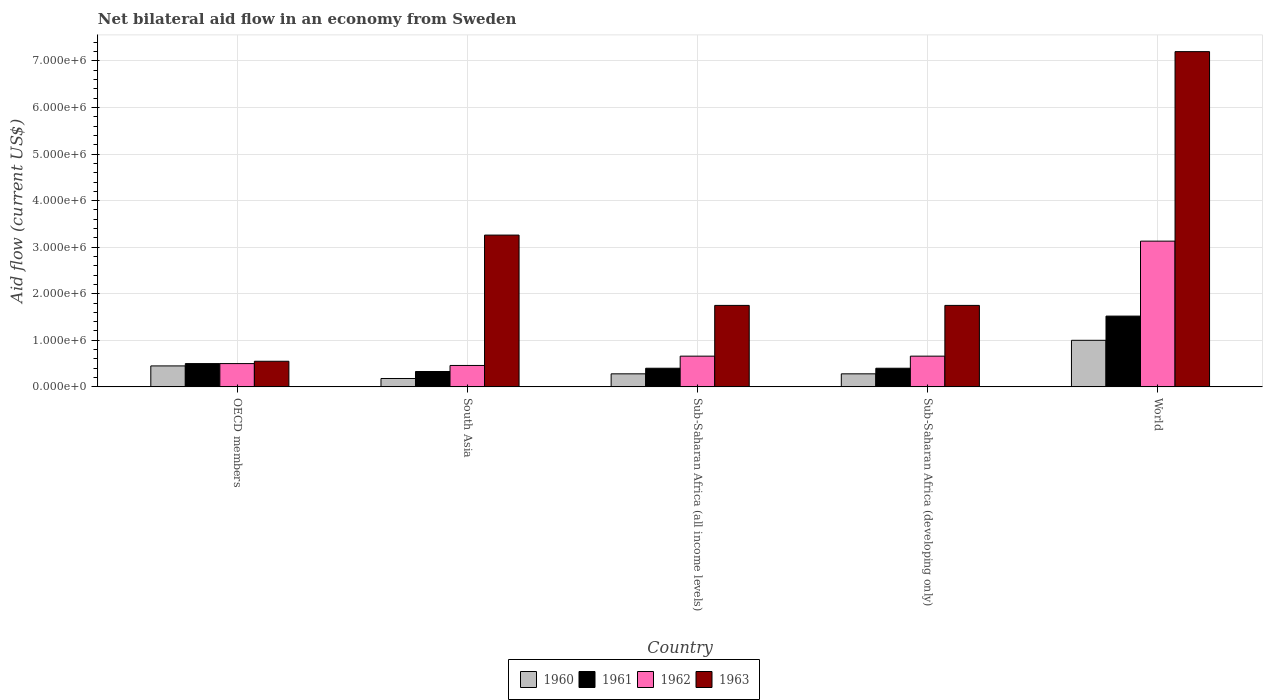How many different coloured bars are there?
Offer a terse response. 4. Are the number of bars per tick equal to the number of legend labels?
Your response must be concise. Yes. Are the number of bars on each tick of the X-axis equal?
Offer a terse response. Yes. What is the label of the 4th group of bars from the left?
Keep it short and to the point. Sub-Saharan Africa (developing only). What is the net bilateral aid flow in 1963 in Sub-Saharan Africa (developing only)?
Ensure brevity in your answer.  1.75e+06. Across all countries, what is the maximum net bilateral aid flow in 1961?
Offer a terse response. 1.52e+06. Across all countries, what is the minimum net bilateral aid flow in 1961?
Make the answer very short. 3.30e+05. In which country was the net bilateral aid flow in 1963 minimum?
Your response must be concise. OECD members. What is the total net bilateral aid flow in 1962 in the graph?
Keep it short and to the point. 5.41e+06. What is the difference between the net bilateral aid flow in 1962 in OECD members and that in Sub-Saharan Africa (developing only)?
Offer a very short reply. -1.60e+05. What is the difference between the net bilateral aid flow in 1963 in Sub-Saharan Africa (all income levels) and the net bilateral aid flow in 1960 in Sub-Saharan Africa (developing only)?
Your answer should be very brief. 1.47e+06. What is the average net bilateral aid flow in 1961 per country?
Your response must be concise. 6.30e+05. In how many countries, is the net bilateral aid flow in 1960 greater than 5200000 US$?
Offer a terse response. 0. What is the ratio of the net bilateral aid flow in 1961 in South Asia to that in Sub-Saharan Africa (all income levels)?
Give a very brief answer. 0.82. Is the difference between the net bilateral aid flow in 1962 in South Asia and World greater than the difference between the net bilateral aid flow in 1960 in South Asia and World?
Your response must be concise. No. What is the difference between the highest and the second highest net bilateral aid flow in 1960?
Offer a terse response. 7.20e+05. What is the difference between the highest and the lowest net bilateral aid flow in 1963?
Keep it short and to the point. 6.65e+06. Is it the case that in every country, the sum of the net bilateral aid flow in 1960 and net bilateral aid flow in 1961 is greater than the sum of net bilateral aid flow in 1963 and net bilateral aid flow in 1962?
Your response must be concise. No. What does the 2nd bar from the right in Sub-Saharan Africa (all income levels) represents?
Your answer should be compact. 1962. Is it the case that in every country, the sum of the net bilateral aid flow in 1963 and net bilateral aid flow in 1960 is greater than the net bilateral aid flow in 1962?
Make the answer very short. Yes. How many bars are there?
Your response must be concise. 20. How many countries are there in the graph?
Give a very brief answer. 5. Are the values on the major ticks of Y-axis written in scientific E-notation?
Your answer should be very brief. Yes. Where does the legend appear in the graph?
Your answer should be compact. Bottom center. How many legend labels are there?
Provide a short and direct response. 4. What is the title of the graph?
Your answer should be very brief. Net bilateral aid flow in an economy from Sweden. What is the Aid flow (current US$) of 1961 in OECD members?
Ensure brevity in your answer.  5.00e+05. What is the Aid flow (current US$) in 1963 in OECD members?
Ensure brevity in your answer.  5.50e+05. What is the Aid flow (current US$) of 1960 in South Asia?
Keep it short and to the point. 1.80e+05. What is the Aid flow (current US$) of 1962 in South Asia?
Keep it short and to the point. 4.60e+05. What is the Aid flow (current US$) in 1963 in South Asia?
Offer a very short reply. 3.26e+06. What is the Aid flow (current US$) in 1962 in Sub-Saharan Africa (all income levels)?
Provide a succinct answer. 6.60e+05. What is the Aid flow (current US$) of 1963 in Sub-Saharan Africa (all income levels)?
Provide a succinct answer. 1.75e+06. What is the Aid flow (current US$) of 1960 in Sub-Saharan Africa (developing only)?
Offer a terse response. 2.80e+05. What is the Aid flow (current US$) in 1961 in Sub-Saharan Africa (developing only)?
Give a very brief answer. 4.00e+05. What is the Aid flow (current US$) in 1963 in Sub-Saharan Africa (developing only)?
Your answer should be compact. 1.75e+06. What is the Aid flow (current US$) in 1961 in World?
Keep it short and to the point. 1.52e+06. What is the Aid flow (current US$) in 1962 in World?
Ensure brevity in your answer.  3.13e+06. What is the Aid flow (current US$) of 1963 in World?
Ensure brevity in your answer.  7.20e+06. Across all countries, what is the maximum Aid flow (current US$) of 1960?
Give a very brief answer. 1.00e+06. Across all countries, what is the maximum Aid flow (current US$) in 1961?
Make the answer very short. 1.52e+06. Across all countries, what is the maximum Aid flow (current US$) of 1962?
Provide a succinct answer. 3.13e+06. Across all countries, what is the maximum Aid flow (current US$) in 1963?
Make the answer very short. 7.20e+06. Across all countries, what is the minimum Aid flow (current US$) of 1960?
Offer a terse response. 1.80e+05. Across all countries, what is the minimum Aid flow (current US$) of 1961?
Keep it short and to the point. 3.30e+05. Across all countries, what is the minimum Aid flow (current US$) in 1963?
Your answer should be very brief. 5.50e+05. What is the total Aid flow (current US$) of 1960 in the graph?
Give a very brief answer. 2.19e+06. What is the total Aid flow (current US$) in 1961 in the graph?
Your answer should be very brief. 3.15e+06. What is the total Aid flow (current US$) in 1962 in the graph?
Your answer should be compact. 5.41e+06. What is the total Aid flow (current US$) in 1963 in the graph?
Offer a very short reply. 1.45e+07. What is the difference between the Aid flow (current US$) of 1960 in OECD members and that in South Asia?
Offer a very short reply. 2.70e+05. What is the difference between the Aid flow (current US$) in 1961 in OECD members and that in South Asia?
Give a very brief answer. 1.70e+05. What is the difference between the Aid flow (current US$) of 1962 in OECD members and that in South Asia?
Offer a very short reply. 4.00e+04. What is the difference between the Aid flow (current US$) in 1963 in OECD members and that in South Asia?
Your answer should be compact. -2.71e+06. What is the difference between the Aid flow (current US$) in 1961 in OECD members and that in Sub-Saharan Africa (all income levels)?
Keep it short and to the point. 1.00e+05. What is the difference between the Aid flow (current US$) of 1962 in OECD members and that in Sub-Saharan Africa (all income levels)?
Keep it short and to the point. -1.60e+05. What is the difference between the Aid flow (current US$) in 1963 in OECD members and that in Sub-Saharan Africa (all income levels)?
Offer a terse response. -1.20e+06. What is the difference between the Aid flow (current US$) of 1960 in OECD members and that in Sub-Saharan Africa (developing only)?
Ensure brevity in your answer.  1.70e+05. What is the difference between the Aid flow (current US$) of 1962 in OECD members and that in Sub-Saharan Africa (developing only)?
Your answer should be compact. -1.60e+05. What is the difference between the Aid flow (current US$) of 1963 in OECD members and that in Sub-Saharan Africa (developing only)?
Provide a short and direct response. -1.20e+06. What is the difference between the Aid flow (current US$) of 1960 in OECD members and that in World?
Keep it short and to the point. -5.50e+05. What is the difference between the Aid flow (current US$) of 1961 in OECD members and that in World?
Offer a very short reply. -1.02e+06. What is the difference between the Aid flow (current US$) in 1962 in OECD members and that in World?
Make the answer very short. -2.63e+06. What is the difference between the Aid flow (current US$) of 1963 in OECD members and that in World?
Your answer should be very brief. -6.65e+06. What is the difference between the Aid flow (current US$) of 1961 in South Asia and that in Sub-Saharan Africa (all income levels)?
Give a very brief answer. -7.00e+04. What is the difference between the Aid flow (current US$) in 1963 in South Asia and that in Sub-Saharan Africa (all income levels)?
Your response must be concise. 1.51e+06. What is the difference between the Aid flow (current US$) in 1960 in South Asia and that in Sub-Saharan Africa (developing only)?
Ensure brevity in your answer.  -1.00e+05. What is the difference between the Aid flow (current US$) in 1963 in South Asia and that in Sub-Saharan Africa (developing only)?
Provide a short and direct response. 1.51e+06. What is the difference between the Aid flow (current US$) of 1960 in South Asia and that in World?
Your response must be concise. -8.20e+05. What is the difference between the Aid flow (current US$) of 1961 in South Asia and that in World?
Make the answer very short. -1.19e+06. What is the difference between the Aid flow (current US$) of 1962 in South Asia and that in World?
Provide a succinct answer. -2.67e+06. What is the difference between the Aid flow (current US$) of 1963 in South Asia and that in World?
Your response must be concise. -3.94e+06. What is the difference between the Aid flow (current US$) of 1960 in Sub-Saharan Africa (all income levels) and that in Sub-Saharan Africa (developing only)?
Offer a terse response. 0. What is the difference between the Aid flow (current US$) in 1960 in Sub-Saharan Africa (all income levels) and that in World?
Your answer should be compact. -7.20e+05. What is the difference between the Aid flow (current US$) of 1961 in Sub-Saharan Africa (all income levels) and that in World?
Your answer should be very brief. -1.12e+06. What is the difference between the Aid flow (current US$) in 1962 in Sub-Saharan Africa (all income levels) and that in World?
Provide a short and direct response. -2.47e+06. What is the difference between the Aid flow (current US$) in 1963 in Sub-Saharan Africa (all income levels) and that in World?
Ensure brevity in your answer.  -5.45e+06. What is the difference between the Aid flow (current US$) in 1960 in Sub-Saharan Africa (developing only) and that in World?
Provide a succinct answer. -7.20e+05. What is the difference between the Aid flow (current US$) of 1961 in Sub-Saharan Africa (developing only) and that in World?
Offer a very short reply. -1.12e+06. What is the difference between the Aid flow (current US$) in 1962 in Sub-Saharan Africa (developing only) and that in World?
Ensure brevity in your answer.  -2.47e+06. What is the difference between the Aid flow (current US$) in 1963 in Sub-Saharan Africa (developing only) and that in World?
Your answer should be compact. -5.45e+06. What is the difference between the Aid flow (current US$) in 1960 in OECD members and the Aid flow (current US$) in 1961 in South Asia?
Your response must be concise. 1.20e+05. What is the difference between the Aid flow (current US$) of 1960 in OECD members and the Aid flow (current US$) of 1963 in South Asia?
Your answer should be very brief. -2.81e+06. What is the difference between the Aid flow (current US$) in 1961 in OECD members and the Aid flow (current US$) in 1962 in South Asia?
Make the answer very short. 4.00e+04. What is the difference between the Aid flow (current US$) in 1961 in OECD members and the Aid flow (current US$) in 1963 in South Asia?
Provide a short and direct response. -2.76e+06. What is the difference between the Aid flow (current US$) of 1962 in OECD members and the Aid flow (current US$) of 1963 in South Asia?
Provide a short and direct response. -2.76e+06. What is the difference between the Aid flow (current US$) of 1960 in OECD members and the Aid flow (current US$) of 1961 in Sub-Saharan Africa (all income levels)?
Your answer should be compact. 5.00e+04. What is the difference between the Aid flow (current US$) of 1960 in OECD members and the Aid flow (current US$) of 1962 in Sub-Saharan Africa (all income levels)?
Offer a very short reply. -2.10e+05. What is the difference between the Aid flow (current US$) in 1960 in OECD members and the Aid flow (current US$) in 1963 in Sub-Saharan Africa (all income levels)?
Your answer should be very brief. -1.30e+06. What is the difference between the Aid flow (current US$) of 1961 in OECD members and the Aid flow (current US$) of 1962 in Sub-Saharan Africa (all income levels)?
Give a very brief answer. -1.60e+05. What is the difference between the Aid flow (current US$) of 1961 in OECD members and the Aid flow (current US$) of 1963 in Sub-Saharan Africa (all income levels)?
Make the answer very short. -1.25e+06. What is the difference between the Aid flow (current US$) of 1962 in OECD members and the Aid flow (current US$) of 1963 in Sub-Saharan Africa (all income levels)?
Provide a succinct answer. -1.25e+06. What is the difference between the Aid flow (current US$) of 1960 in OECD members and the Aid flow (current US$) of 1961 in Sub-Saharan Africa (developing only)?
Provide a short and direct response. 5.00e+04. What is the difference between the Aid flow (current US$) of 1960 in OECD members and the Aid flow (current US$) of 1962 in Sub-Saharan Africa (developing only)?
Your answer should be compact. -2.10e+05. What is the difference between the Aid flow (current US$) in 1960 in OECD members and the Aid flow (current US$) in 1963 in Sub-Saharan Africa (developing only)?
Give a very brief answer. -1.30e+06. What is the difference between the Aid flow (current US$) of 1961 in OECD members and the Aid flow (current US$) of 1962 in Sub-Saharan Africa (developing only)?
Provide a succinct answer. -1.60e+05. What is the difference between the Aid flow (current US$) of 1961 in OECD members and the Aid flow (current US$) of 1963 in Sub-Saharan Africa (developing only)?
Make the answer very short. -1.25e+06. What is the difference between the Aid flow (current US$) in 1962 in OECD members and the Aid flow (current US$) in 1963 in Sub-Saharan Africa (developing only)?
Make the answer very short. -1.25e+06. What is the difference between the Aid flow (current US$) of 1960 in OECD members and the Aid flow (current US$) of 1961 in World?
Ensure brevity in your answer.  -1.07e+06. What is the difference between the Aid flow (current US$) in 1960 in OECD members and the Aid flow (current US$) in 1962 in World?
Make the answer very short. -2.68e+06. What is the difference between the Aid flow (current US$) of 1960 in OECD members and the Aid flow (current US$) of 1963 in World?
Give a very brief answer. -6.75e+06. What is the difference between the Aid flow (current US$) of 1961 in OECD members and the Aid flow (current US$) of 1962 in World?
Offer a terse response. -2.63e+06. What is the difference between the Aid flow (current US$) in 1961 in OECD members and the Aid flow (current US$) in 1963 in World?
Your answer should be very brief. -6.70e+06. What is the difference between the Aid flow (current US$) of 1962 in OECD members and the Aid flow (current US$) of 1963 in World?
Ensure brevity in your answer.  -6.70e+06. What is the difference between the Aid flow (current US$) of 1960 in South Asia and the Aid flow (current US$) of 1962 in Sub-Saharan Africa (all income levels)?
Your response must be concise. -4.80e+05. What is the difference between the Aid flow (current US$) in 1960 in South Asia and the Aid flow (current US$) in 1963 in Sub-Saharan Africa (all income levels)?
Offer a very short reply. -1.57e+06. What is the difference between the Aid flow (current US$) in 1961 in South Asia and the Aid flow (current US$) in 1962 in Sub-Saharan Africa (all income levels)?
Provide a succinct answer. -3.30e+05. What is the difference between the Aid flow (current US$) in 1961 in South Asia and the Aid flow (current US$) in 1963 in Sub-Saharan Africa (all income levels)?
Your response must be concise. -1.42e+06. What is the difference between the Aid flow (current US$) in 1962 in South Asia and the Aid flow (current US$) in 1963 in Sub-Saharan Africa (all income levels)?
Your answer should be very brief. -1.29e+06. What is the difference between the Aid flow (current US$) in 1960 in South Asia and the Aid flow (current US$) in 1962 in Sub-Saharan Africa (developing only)?
Ensure brevity in your answer.  -4.80e+05. What is the difference between the Aid flow (current US$) in 1960 in South Asia and the Aid flow (current US$) in 1963 in Sub-Saharan Africa (developing only)?
Offer a terse response. -1.57e+06. What is the difference between the Aid flow (current US$) in 1961 in South Asia and the Aid flow (current US$) in 1962 in Sub-Saharan Africa (developing only)?
Keep it short and to the point. -3.30e+05. What is the difference between the Aid flow (current US$) in 1961 in South Asia and the Aid flow (current US$) in 1963 in Sub-Saharan Africa (developing only)?
Offer a very short reply. -1.42e+06. What is the difference between the Aid flow (current US$) of 1962 in South Asia and the Aid flow (current US$) of 1963 in Sub-Saharan Africa (developing only)?
Offer a terse response. -1.29e+06. What is the difference between the Aid flow (current US$) of 1960 in South Asia and the Aid flow (current US$) of 1961 in World?
Your answer should be compact. -1.34e+06. What is the difference between the Aid flow (current US$) of 1960 in South Asia and the Aid flow (current US$) of 1962 in World?
Offer a very short reply. -2.95e+06. What is the difference between the Aid flow (current US$) of 1960 in South Asia and the Aid flow (current US$) of 1963 in World?
Offer a terse response. -7.02e+06. What is the difference between the Aid flow (current US$) in 1961 in South Asia and the Aid flow (current US$) in 1962 in World?
Offer a terse response. -2.80e+06. What is the difference between the Aid flow (current US$) of 1961 in South Asia and the Aid flow (current US$) of 1963 in World?
Offer a terse response. -6.87e+06. What is the difference between the Aid flow (current US$) in 1962 in South Asia and the Aid flow (current US$) in 1963 in World?
Offer a terse response. -6.74e+06. What is the difference between the Aid flow (current US$) of 1960 in Sub-Saharan Africa (all income levels) and the Aid flow (current US$) of 1962 in Sub-Saharan Africa (developing only)?
Keep it short and to the point. -3.80e+05. What is the difference between the Aid flow (current US$) of 1960 in Sub-Saharan Africa (all income levels) and the Aid flow (current US$) of 1963 in Sub-Saharan Africa (developing only)?
Offer a very short reply. -1.47e+06. What is the difference between the Aid flow (current US$) of 1961 in Sub-Saharan Africa (all income levels) and the Aid flow (current US$) of 1962 in Sub-Saharan Africa (developing only)?
Your answer should be compact. -2.60e+05. What is the difference between the Aid flow (current US$) of 1961 in Sub-Saharan Africa (all income levels) and the Aid flow (current US$) of 1963 in Sub-Saharan Africa (developing only)?
Your answer should be compact. -1.35e+06. What is the difference between the Aid flow (current US$) in 1962 in Sub-Saharan Africa (all income levels) and the Aid flow (current US$) in 1963 in Sub-Saharan Africa (developing only)?
Provide a short and direct response. -1.09e+06. What is the difference between the Aid flow (current US$) of 1960 in Sub-Saharan Africa (all income levels) and the Aid flow (current US$) of 1961 in World?
Your answer should be compact. -1.24e+06. What is the difference between the Aid flow (current US$) of 1960 in Sub-Saharan Africa (all income levels) and the Aid flow (current US$) of 1962 in World?
Ensure brevity in your answer.  -2.85e+06. What is the difference between the Aid flow (current US$) in 1960 in Sub-Saharan Africa (all income levels) and the Aid flow (current US$) in 1963 in World?
Give a very brief answer. -6.92e+06. What is the difference between the Aid flow (current US$) in 1961 in Sub-Saharan Africa (all income levels) and the Aid flow (current US$) in 1962 in World?
Your answer should be very brief. -2.73e+06. What is the difference between the Aid flow (current US$) of 1961 in Sub-Saharan Africa (all income levels) and the Aid flow (current US$) of 1963 in World?
Make the answer very short. -6.80e+06. What is the difference between the Aid flow (current US$) of 1962 in Sub-Saharan Africa (all income levels) and the Aid flow (current US$) of 1963 in World?
Keep it short and to the point. -6.54e+06. What is the difference between the Aid flow (current US$) of 1960 in Sub-Saharan Africa (developing only) and the Aid flow (current US$) of 1961 in World?
Provide a short and direct response. -1.24e+06. What is the difference between the Aid flow (current US$) in 1960 in Sub-Saharan Africa (developing only) and the Aid flow (current US$) in 1962 in World?
Offer a very short reply. -2.85e+06. What is the difference between the Aid flow (current US$) of 1960 in Sub-Saharan Africa (developing only) and the Aid flow (current US$) of 1963 in World?
Provide a succinct answer. -6.92e+06. What is the difference between the Aid flow (current US$) of 1961 in Sub-Saharan Africa (developing only) and the Aid flow (current US$) of 1962 in World?
Offer a terse response. -2.73e+06. What is the difference between the Aid flow (current US$) of 1961 in Sub-Saharan Africa (developing only) and the Aid flow (current US$) of 1963 in World?
Provide a succinct answer. -6.80e+06. What is the difference between the Aid flow (current US$) in 1962 in Sub-Saharan Africa (developing only) and the Aid flow (current US$) in 1963 in World?
Offer a terse response. -6.54e+06. What is the average Aid flow (current US$) of 1960 per country?
Provide a succinct answer. 4.38e+05. What is the average Aid flow (current US$) in 1961 per country?
Offer a terse response. 6.30e+05. What is the average Aid flow (current US$) of 1962 per country?
Your answer should be compact. 1.08e+06. What is the average Aid flow (current US$) of 1963 per country?
Your answer should be compact. 2.90e+06. What is the difference between the Aid flow (current US$) in 1960 and Aid flow (current US$) in 1961 in OECD members?
Your answer should be compact. -5.00e+04. What is the difference between the Aid flow (current US$) of 1960 and Aid flow (current US$) of 1962 in OECD members?
Your answer should be very brief. -5.00e+04. What is the difference between the Aid flow (current US$) of 1960 and Aid flow (current US$) of 1963 in OECD members?
Your answer should be very brief. -1.00e+05. What is the difference between the Aid flow (current US$) of 1962 and Aid flow (current US$) of 1963 in OECD members?
Your response must be concise. -5.00e+04. What is the difference between the Aid flow (current US$) in 1960 and Aid flow (current US$) in 1962 in South Asia?
Make the answer very short. -2.80e+05. What is the difference between the Aid flow (current US$) in 1960 and Aid flow (current US$) in 1963 in South Asia?
Ensure brevity in your answer.  -3.08e+06. What is the difference between the Aid flow (current US$) of 1961 and Aid flow (current US$) of 1962 in South Asia?
Offer a very short reply. -1.30e+05. What is the difference between the Aid flow (current US$) in 1961 and Aid flow (current US$) in 1963 in South Asia?
Ensure brevity in your answer.  -2.93e+06. What is the difference between the Aid flow (current US$) of 1962 and Aid flow (current US$) of 1963 in South Asia?
Ensure brevity in your answer.  -2.80e+06. What is the difference between the Aid flow (current US$) of 1960 and Aid flow (current US$) of 1961 in Sub-Saharan Africa (all income levels)?
Provide a short and direct response. -1.20e+05. What is the difference between the Aid flow (current US$) in 1960 and Aid flow (current US$) in 1962 in Sub-Saharan Africa (all income levels)?
Your answer should be very brief. -3.80e+05. What is the difference between the Aid flow (current US$) in 1960 and Aid flow (current US$) in 1963 in Sub-Saharan Africa (all income levels)?
Your response must be concise. -1.47e+06. What is the difference between the Aid flow (current US$) in 1961 and Aid flow (current US$) in 1962 in Sub-Saharan Africa (all income levels)?
Offer a very short reply. -2.60e+05. What is the difference between the Aid flow (current US$) of 1961 and Aid flow (current US$) of 1963 in Sub-Saharan Africa (all income levels)?
Your answer should be very brief. -1.35e+06. What is the difference between the Aid flow (current US$) in 1962 and Aid flow (current US$) in 1963 in Sub-Saharan Africa (all income levels)?
Keep it short and to the point. -1.09e+06. What is the difference between the Aid flow (current US$) of 1960 and Aid flow (current US$) of 1961 in Sub-Saharan Africa (developing only)?
Provide a short and direct response. -1.20e+05. What is the difference between the Aid flow (current US$) in 1960 and Aid flow (current US$) in 1962 in Sub-Saharan Africa (developing only)?
Make the answer very short. -3.80e+05. What is the difference between the Aid flow (current US$) of 1960 and Aid flow (current US$) of 1963 in Sub-Saharan Africa (developing only)?
Ensure brevity in your answer.  -1.47e+06. What is the difference between the Aid flow (current US$) in 1961 and Aid flow (current US$) in 1963 in Sub-Saharan Africa (developing only)?
Offer a terse response. -1.35e+06. What is the difference between the Aid flow (current US$) in 1962 and Aid flow (current US$) in 1963 in Sub-Saharan Africa (developing only)?
Keep it short and to the point. -1.09e+06. What is the difference between the Aid flow (current US$) of 1960 and Aid flow (current US$) of 1961 in World?
Provide a succinct answer. -5.20e+05. What is the difference between the Aid flow (current US$) in 1960 and Aid flow (current US$) in 1962 in World?
Your answer should be very brief. -2.13e+06. What is the difference between the Aid flow (current US$) in 1960 and Aid flow (current US$) in 1963 in World?
Offer a terse response. -6.20e+06. What is the difference between the Aid flow (current US$) of 1961 and Aid flow (current US$) of 1962 in World?
Your response must be concise. -1.61e+06. What is the difference between the Aid flow (current US$) of 1961 and Aid flow (current US$) of 1963 in World?
Your answer should be very brief. -5.68e+06. What is the difference between the Aid flow (current US$) of 1962 and Aid flow (current US$) of 1963 in World?
Provide a succinct answer. -4.07e+06. What is the ratio of the Aid flow (current US$) of 1961 in OECD members to that in South Asia?
Offer a very short reply. 1.52. What is the ratio of the Aid flow (current US$) of 1962 in OECD members to that in South Asia?
Make the answer very short. 1.09. What is the ratio of the Aid flow (current US$) of 1963 in OECD members to that in South Asia?
Your answer should be very brief. 0.17. What is the ratio of the Aid flow (current US$) in 1960 in OECD members to that in Sub-Saharan Africa (all income levels)?
Your response must be concise. 1.61. What is the ratio of the Aid flow (current US$) of 1961 in OECD members to that in Sub-Saharan Africa (all income levels)?
Make the answer very short. 1.25. What is the ratio of the Aid flow (current US$) of 1962 in OECD members to that in Sub-Saharan Africa (all income levels)?
Provide a succinct answer. 0.76. What is the ratio of the Aid flow (current US$) in 1963 in OECD members to that in Sub-Saharan Africa (all income levels)?
Make the answer very short. 0.31. What is the ratio of the Aid flow (current US$) in 1960 in OECD members to that in Sub-Saharan Africa (developing only)?
Your answer should be compact. 1.61. What is the ratio of the Aid flow (current US$) in 1962 in OECD members to that in Sub-Saharan Africa (developing only)?
Your response must be concise. 0.76. What is the ratio of the Aid flow (current US$) in 1963 in OECD members to that in Sub-Saharan Africa (developing only)?
Keep it short and to the point. 0.31. What is the ratio of the Aid flow (current US$) in 1960 in OECD members to that in World?
Your answer should be very brief. 0.45. What is the ratio of the Aid flow (current US$) of 1961 in OECD members to that in World?
Your response must be concise. 0.33. What is the ratio of the Aid flow (current US$) in 1962 in OECD members to that in World?
Make the answer very short. 0.16. What is the ratio of the Aid flow (current US$) in 1963 in OECD members to that in World?
Keep it short and to the point. 0.08. What is the ratio of the Aid flow (current US$) of 1960 in South Asia to that in Sub-Saharan Africa (all income levels)?
Your response must be concise. 0.64. What is the ratio of the Aid flow (current US$) in 1961 in South Asia to that in Sub-Saharan Africa (all income levels)?
Offer a terse response. 0.82. What is the ratio of the Aid flow (current US$) of 1962 in South Asia to that in Sub-Saharan Africa (all income levels)?
Offer a very short reply. 0.7. What is the ratio of the Aid flow (current US$) of 1963 in South Asia to that in Sub-Saharan Africa (all income levels)?
Provide a short and direct response. 1.86. What is the ratio of the Aid flow (current US$) of 1960 in South Asia to that in Sub-Saharan Africa (developing only)?
Your response must be concise. 0.64. What is the ratio of the Aid flow (current US$) in 1961 in South Asia to that in Sub-Saharan Africa (developing only)?
Your response must be concise. 0.82. What is the ratio of the Aid flow (current US$) in 1962 in South Asia to that in Sub-Saharan Africa (developing only)?
Give a very brief answer. 0.7. What is the ratio of the Aid flow (current US$) of 1963 in South Asia to that in Sub-Saharan Africa (developing only)?
Your answer should be very brief. 1.86. What is the ratio of the Aid flow (current US$) in 1960 in South Asia to that in World?
Your answer should be very brief. 0.18. What is the ratio of the Aid flow (current US$) in 1961 in South Asia to that in World?
Make the answer very short. 0.22. What is the ratio of the Aid flow (current US$) in 1962 in South Asia to that in World?
Give a very brief answer. 0.15. What is the ratio of the Aid flow (current US$) of 1963 in South Asia to that in World?
Provide a short and direct response. 0.45. What is the ratio of the Aid flow (current US$) in 1960 in Sub-Saharan Africa (all income levels) to that in World?
Give a very brief answer. 0.28. What is the ratio of the Aid flow (current US$) of 1961 in Sub-Saharan Africa (all income levels) to that in World?
Your answer should be compact. 0.26. What is the ratio of the Aid flow (current US$) of 1962 in Sub-Saharan Africa (all income levels) to that in World?
Your answer should be very brief. 0.21. What is the ratio of the Aid flow (current US$) of 1963 in Sub-Saharan Africa (all income levels) to that in World?
Make the answer very short. 0.24. What is the ratio of the Aid flow (current US$) of 1960 in Sub-Saharan Africa (developing only) to that in World?
Your response must be concise. 0.28. What is the ratio of the Aid flow (current US$) of 1961 in Sub-Saharan Africa (developing only) to that in World?
Offer a very short reply. 0.26. What is the ratio of the Aid flow (current US$) of 1962 in Sub-Saharan Africa (developing only) to that in World?
Offer a very short reply. 0.21. What is the ratio of the Aid flow (current US$) of 1963 in Sub-Saharan Africa (developing only) to that in World?
Provide a short and direct response. 0.24. What is the difference between the highest and the second highest Aid flow (current US$) of 1961?
Keep it short and to the point. 1.02e+06. What is the difference between the highest and the second highest Aid flow (current US$) of 1962?
Your response must be concise. 2.47e+06. What is the difference between the highest and the second highest Aid flow (current US$) of 1963?
Keep it short and to the point. 3.94e+06. What is the difference between the highest and the lowest Aid flow (current US$) of 1960?
Offer a very short reply. 8.20e+05. What is the difference between the highest and the lowest Aid flow (current US$) in 1961?
Provide a succinct answer. 1.19e+06. What is the difference between the highest and the lowest Aid flow (current US$) in 1962?
Your answer should be very brief. 2.67e+06. What is the difference between the highest and the lowest Aid flow (current US$) in 1963?
Ensure brevity in your answer.  6.65e+06. 